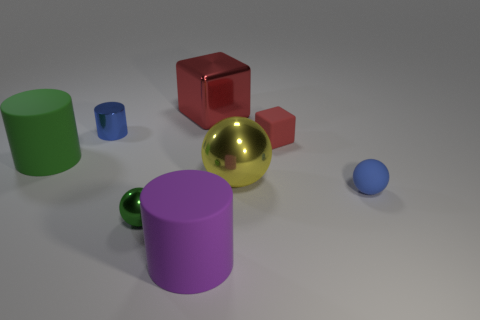Subtract all large purple cylinders. How many cylinders are left? 2 Add 2 tiny things. How many objects exist? 10 Subtract all blue balls. How many balls are left? 2 Subtract all cylinders. How many objects are left? 5 Subtract 2 cubes. How many cubes are left? 0 Subtract all small blue matte things. Subtract all tiny green rubber balls. How many objects are left? 7 Add 3 green cylinders. How many green cylinders are left? 4 Add 8 tiny green matte things. How many tiny green matte things exist? 8 Subtract 0 blue blocks. How many objects are left? 8 Subtract all blue balls. Subtract all brown cylinders. How many balls are left? 2 